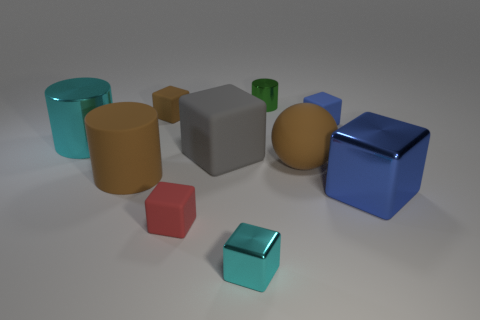Subtract all small green metallic cylinders. How many cylinders are left? 2 Subtract all cylinders. How many objects are left? 7 Subtract all cyan cubes. How many cubes are left? 5 Subtract 3 cylinders. How many cylinders are left? 0 Subtract all brown blocks. Subtract all yellow cylinders. How many blocks are left? 5 Subtract all blue balls. How many yellow blocks are left? 0 Subtract all gray rubber blocks. Subtract all blue things. How many objects are left? 7 Add 8 big cylinders. How many big cylinders are left? 10 Add 3 big blue metallic cubes. How many big blue metallic cubes exist? 4 Subtract 1 gray blocks. How many objects are left? 9 